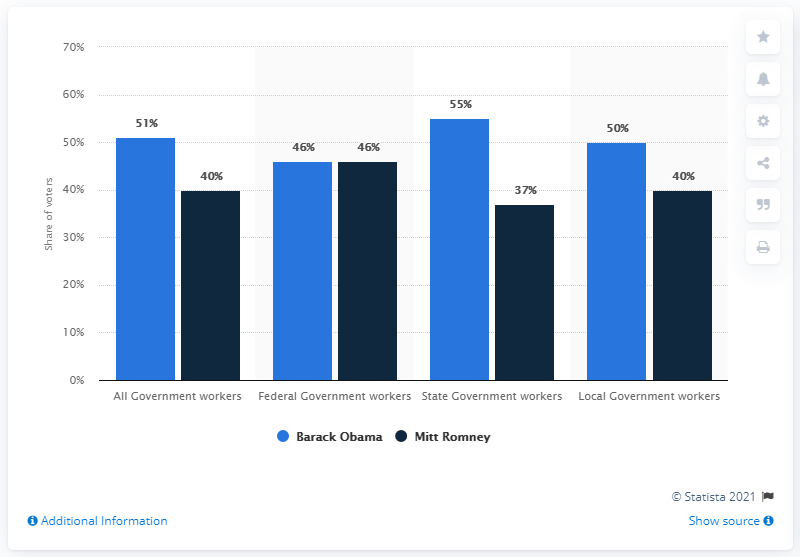Outline some significant characteristics in this image. According to the data, a voter group with an equal percentage of preference for Barack Obama and Mitt Romney is Federal Government workers. In 2012, 55% of state government workers preferred Barack Obama. 